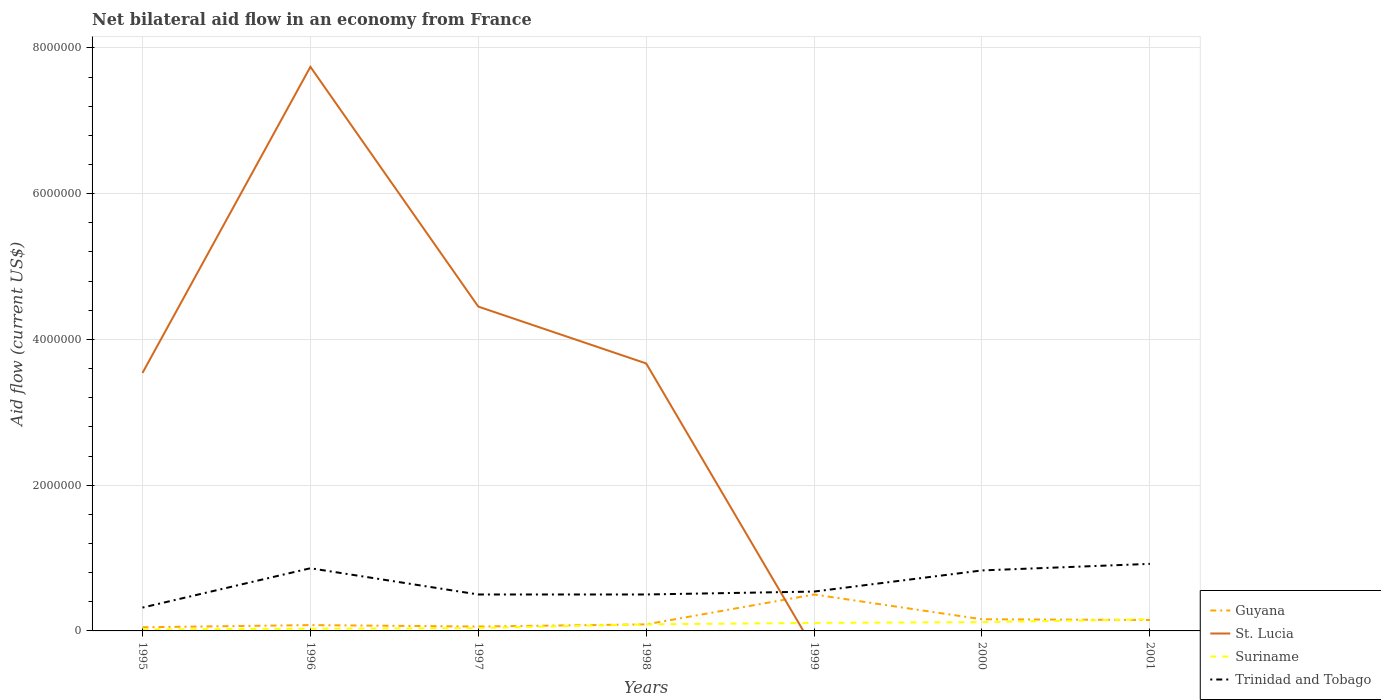Across all years, what is the maximum net bilateral aid flow in Suriname?
Ensure brevity in your answer.  2.00e+04. What is the total net bilateral aid flow in Trinidad and Tobago in the graph?
Offer a terse response. 0. How many lines are there?
Provide a succinct answer. 4. Are the values on the major ticks of Y-axis written in scientific E-notation?
Give a very brief answer. No. Does the graph contain any zero values?
Make the answer very short. Yes. What is the title of the graph?
Make the answer very short. Net bilateral aid flow in an economy from France. Does "Benin" appear as one of the legend labels in the graph?
Make the answer very short. No. What is the Aid flow (current US$) of Guyana in 1995?
Your response must be concise. 5.00e+04. What is the Aid flow (current US$) of St. Lucia in 1995?
Keep it short and to the point. 3.54e+06. What is the Aid flow (current US$) of Suriname in 1995?
Your answer should be very brief. 2.00e+04. What is the Aid flow (current US$) of St. Lucia in 1996?
Ensure brevity in your answer.  7.74e+06. What is the Aid flow (current US$) in Suriname in 1996?
Make the answer very short. 3.00e+04. What is the Aid flow (current US$) in Trinidad and Tobago in 1996?
Ensure brevity in your answer.  8.60e+05. What is the Aid flow (current US$) of Guyana in 1997?
Ensure brevity in your answer.  6.00e+04. What is the Aid flow (current US$) in St. Lucia in 1997?
Make the answer very short. 4.45e+06. What is the Aid flow (current US$) in Suriname in 1997?
Offer a terse response. 4.00e+04. What is the Aid flow (current US$) of St. Lucia in 1998?
Keep it short and to the point. 3.67e+06. What is the Aid flow (current US$) in Suriname in 1998?
Your response must be concise. 9.00e+04. What is the Aid flow (current US$) of Trinidad and Tobago in 1998?
Provide a short and direct response. 5.00e+05. What is the Aid flow (current US$) in Guyana in 1999?
Provide a short and direct response. 5.00e+05. What is the Aid flow (current US$) of Suriname in 1999?
Your answer should be very brief. 1.10e+05. What is the Aid flow (current US$) in Trinidad and Tobago in 1999?
Keep it short and to the point. 5.40e+05. What is the Aid flow (current US$) of St. Lucia in 2000?
Offer a terse response. 0. What is the Aid flow (current US$) in Suriname in 2000?
Offer a very short reply. 1.20e+05. What is the Aid flow (current US$) of Trinidad and Tobago in 2000?
Keep it short and to the point. 8.30e+05. What is the Aid flow (current US$) of Guyana in 2001?
Offer a terse response. 1.50e+05. What is the Aid flow (current US$) in St. Lucia in 2001?
Give a very brief answer. 0. What is the Aid flow (current US$) in Suriname in 2001?
Offer a very short reply. 1.60e+05. What is the Aid flow (current US$) of Trinidad and Tobago in 2001?
Give a very brief answer. 9.20e+05. Across all years, what is the maximum Aid flow (current US$) of St. Lucia?
Provide a short and direct response. 7.74e+06. Across all years, what is the maximum Aid flow (current US$) of Trinidad and Tobago?
Keep it short and to the point. 9.20e+05. Across all years, what is the minimum Aid flow (current US$) of St. Lucia?
Make the answer very short. 0. Across all years, what is the minimum Aid flow (current US$) of Suriname?
Your response must be concise. 2.00e+04. Across all years, what is the minimum Aid flow (current US$) in Trinidad and Tobago?
Your answer should be compact. 3.20e+05. What is the total Aid flow (current US$) in Guyana in the graph?
Provide a short and direct response. 1.09e+06. What is the total Aid flow (current US$) in St. Lucia in the graph?
Make the answer very short. 1.94e+07. What is the total Aid flow (current US$) of Suriname in the graph?
Your answer should be compact. 5.70e+05. What is the total Aid flow (current US$) of Trinidad and Tobago in the graph?
Your response must be concise. 4.47e+06. What is the difference between the Aid flow (current US$) of St. Lucia in 1995 and that in 1996?
Give a very brief answer. -4.20e+06. What is the difference between the Aid flow (current US$) in Suriname in 1995 and that in 1996?
Make the answer very short. -10000. What is the difference between the Aid flow (current US$) in Trinidad and Tobago in 1995 and that in 1996?
Your answer should be very brief. -5.40e+05. What is the difference between the Aid flow (current US$) of Guyana in 1995 and that in 1997?
Offer a very short reply. -10000. What is the difference between the Aid flow (current US$) of St. Lucia in 1995 and that in 1997?
Your response must be concise. -9.10e+05. What is the difference between the Aid flow (current US$) of Guyana in 1995 and that in 1998?
Keep it short and to the point. -4.00e+04. What is the difference between the Aid flow (current US$) in St. Lucia in 1995 and that in 1998?
Make the answer very short. -1.30e+05. What is the difference between the Aid flow (current US$) in Trinidad and Tobago in 1995 and that in 1998?
Your answer should be very brief. -1.80e+05. What is the difference between the Aid flow (current US$) of Guyana in 1995 and that in 1999?
Make the answer very short. -4.50e+05. What is the difference between the Aid flow (current US$) of Guyana in 1995 and that in 2000?
Provide a short and direct response. -1.10e+05. What is the difference between the Aid flow (current US$) of Suriname in 1995 and that in 2000?
Ensure brevity in your answer.  -1.00e+05. What is the difference between the Aid flow (current US$) of Trinidad and Tobago in 1995 and that in 2000?
Your response must be concise. -5.10e+05. What is the difference between the Aid flow (current US$) of Suriname in 1995 and that in 2001?
Your response must be concise. -1.40e+05. What is the difference between the Aid flow (current US$) of Trinidad and Tobago in 1995 and that in 2001?
Provide a succinct answer. -6.00e+05. What is the difference between the Aid flow (current US$) in Guyana in 1996 and that in 1997?
Offer a terse response. 2.00e+04. What is the difference between the Aid flow (current US$) of St. Lucia in 1996 and that in 1997?
Provide a succinct answer. 3.29e+06. What is the difference between the Aid flow (current US$) of Trinidad and Tobago in 1996 and that in 1997?
Make the answer very short. 3.60e+05. What is the difference between the Aid flow (current US$) of St. Lucia in 1996 and that in 1998?
Your response must be concise. 4.07e+06. What is the difference between the Aid flow (current US$) of Suriname in 1996 and that in 1998?
Your response must be concise. -6.00e+04. What is the difference between the Aid flow (current US$) of Guyana in 1996 and that in 1999?
Ensure brevity in your answer.  -4.20e+05. What is the difference between the Aid flow (current US$) in Trinidad and Tobago in 1996 and that in 1999?
Make the answer very short. 3.20e+05. What is the difference between the Aid flow (current US$) in Guyana in 1996 and that in 2000?
Provide a short and direct response. -8.00e+04. What is the difference between the Aid flow (current US$) of Trinidad and Tobago in 1996 and that in 2000?
Provide a succinct answer. 3.00e+04. What is the difference between the Aid flow (current US$) in Guyana in 1996 and that in 2001?
Your response must be concise. -7.00e+04. What is the difference between the Aid flow (current US$) of Suriname in 1996 and that in 2001?
Offer a terse response. -1.30e+05. What is the difference between the Aid flow (current US$) in St. Lucia in 1997 and that in 1998?
Offer a terse response. 7.80e+05. What is the difference between the Aid flow (current US$) of Trinidad and Tobago in 1997 and that in 1998?
Offer a very short reply. 0. What is the difference between the Aid flow (current US$) in Guyana in 1997 and that in 1999?
Offer a very short reply. -4.40e+05. What is the difference between the Aid flow (current US$) of Suriname in 1997 and that in 1999?
Give a very brief answer. -7.00e+04. What is the difference between the Aid flow (current US$) of Guyana in 1997 and that in 2000?
Your response must be concise. -1.00e+05. What is the difference between the Aid flow (current US$) of Suriname in 1997 and that in 2000?
Offer a very short reply. -8.00e+04. What is the difference between the Aid flow (current US$) in Trinidad and Tobago in 1997 and that in 2000?
Keep it short and to the point. -3.30e+05. What is the difference between the Aid flow (current US$) in Suriname in 1997 and that in 2001?
Your answer should be very brief. -1.20e+05. What is the difference between the Aid flow (current US$) in Trinidad and Tobago in 1997 and that in 2001?
Make the answer very short. -4.20e+05. What is the difference between the Aid flow (current US$) of Guyana in 1998 and that in 1999?
Offer a terse response. -4.10e+05. What is the difference between the Aid flow (current US$) of Suriname in 1998 and that in 1999?
Provide a succinct answer. -2.00e+04. What is the difference between the Aid flow (current US$) of Guyana in 1998 and that in 2000?
Your response must be concise. -7.00e+04. What is the difference between the Aid flow (current US$) in Trinidad and Tobago in 1998 and that in 2000?
Your response must be concise. -3.30e+05. What is the difference between the Aid flow (current US$) in Guyana in 1998 and that in 2001?
Your response must be concise. -6.00e+04. What is the difference between the Aid flow (current US$) of Suriname in 1998 and that in 2001?
Keep it short and to the point. -7.00e+04. What is the difference between the Aid flow (current US$) of Trinidad and Tobago in 1998 and that in 2001?
Give a very brief answer. -4.20e+05. What is the difference between the Aid flow (current US$) in Guyana in 1999 and that in 2000?
Your response must be concise. 3.40e+05. What is the difference between the Aid flow (current US$) in Trinidad and Tobago in 1999 and that in 2000?
Provide a succinct answer. -2.90e+05. What is the difference between the Aid flow (current US$) in Guyana in 1999 and that in 2001?
Your answer should be very brief. 3.50e+05. What is the difference between the Aid flow (current US$) of Trinidad and Tobago in 1999 and that in 2001?
Give a very brief answer. -3.80e+05. What is the difference between the Aid flow (current US$) of Guyana in 2000 and that in 2001?
Your answer should be very brief. 10000. What is the difference between the Aid flow (current US$) of Suriname in 2000 and that in 2001?
Your answer should be very brief. -4.00e+04. What is the difference between the Aid flow (current US$) in Trinidad and Tobago in 2000 and that in 2001?
Your answer should be compact. -9.00e+04. What is the difference between the Aid flow (current US$) in Guyana in 1995 and the Aid flow (current US$) in St. Lucia in 1996?
Make the answer very short. -7.69e+06. What is the difference between the Aid flow (current US$) of Guyana in 1995 and the Aid flow (current US$) of Trinidad and Tobago in 1996?
Ensure brevity in your answer.  -8.10e+05. What is the difference between the Aid flow (current US$) of St. Lucia in 1995 and the Aid flow (current US$) of Suriname in 1996?
Your answer should be compact. 3.51e+06. What is the difference between the Aid flow (current US$) in St. Lucia in 1995 and the Aid flow (current US$) in Trinidad and Tobago in 1996?
Offer a terse response. 2.68e+06. What is the difference between the Aid flow (current US$) in Suriname in 1995 and the Aid flow (current US$) in Trinidad and Tobago in 1996?
Keep it short and to the point. -8.40e+05. What is the difference between the Aid flow (current US$) in Guyana in 1995 and the Aid flow (current US$) in St. Lucia in 1997?
Keep it short and to the point. -4.40e+06. What is the difference between the Aid flow (current US$) of Guyana in 1995 and the Aid flow (current US$) of Trinidad and Tobago in 1997?
Your answer should be compact. -4.50e+05. What is the difference between the Aid flow (current US$) of St. Lucia in 1995 and the Aid flow (current US$) of Suriname in 1997?
Your response must be concise. 3.50e+06. What is the difference between the Aid flow (current US$) in St. Lucia in 1995 and the Aid flow (current US$) in Trinidad and Tobago in 1997?
Your answer should be very brief. 3.04e+06. What is the difference between the Aid flow (current US$) in Suriname in 1995 and the Aid flow (current US$) in Trinidad and Tobago in 1997?
Provide a short and direct response. -4.80e+05. What is the difference between the Aid flow (current US$) of Guyana in 1995 and the Aid flow (current US$) of St. Lucia in 1998?
Your response must be concise. -3.62e+06. What is the difference between the Aid flow (current US$) of Guyana in 1995 and the Aid flow (current US$) of Trinidad and Tobago in 1998?
Give a very brief answer. -4.50e+05. What is the difference between the Aid flow (current US$) of St. Lucia in 1995 and the Aid flow (current US$) of Suriname in 1998?
Make the answer very short. 3.45e+06. What is the difference between the Aid flow (current US$) in St. Lucia in 1995 and the Aid flow (current US$) in Trinidad and Tobago in 1998?
Offer a very short reply. 3.04e+06. What is the difference between the Aid flow (current US$) in Suriname in 1995 and the Aid flow (current US$) in Trinidad and Tobago in 1998?
Give a very brief answer. -4.80e+05. What is the difference between the Aid flow (current US$) in Guyana in 1995 and the Aid flow (current US$) in Trinidad and Tobago in 1999?
Your answer should be very brief. -4.90e+05. What is the difference between the Aid flow (current US$) of St. Lucia in 1995 and the Aid flow (current US$) of Suriname in 1999?
Ensure brevity in your answer.  3.43e+06. What is the difference between the Aid flow (current US$) of Suriname in 1995 and the Aid flow (current US$) of Trinidad and Tobago in 1999?
Make the answer very short. -5.20e+05. What is the difference between the Aid flow (current US$) in Guyana in 1995 and the Aid flow (current US$) in Trinidad and Tobago in 2000?
Ensure brevity in your answer.  -7.80e+05. What is the difference between the Aid flow (current US$) in St. Lucia in 1995 and the Aid flow (current US$) in Suriname in 2000?
Offer a terse response. 3.42e+06. What is the difference between the Aid flow (current US$) of St. Lucia in 1995 and the Aid flow (current US$) of Trinidad and Tobago in 2000?
Your answer should be very brief. 2.71e+06. What is the difference between the Aid flow (current US$) in Suriname in 1995 and the Aid flow (current US$) in Trinidad and Tobago in 2000?
Provide a succinct answer. -8.10e+05. What is the difference between the Aid flow (current US$) of Guyana in 1995 and the Aid flow (current US$) of Trinidad and Tobago in 2001?
Make the answer very short. -8.70e+05. What is the difference between the Aid flow (current US$) in St. Lucia in 1995 and the Aid flow (current US$) in Suriname in 2001?
Ensure brevity in your answer.  3.38e+06. What is the difference between the Aid flow (current US$) of St. Lucia in 1995 and the Aid flow (current US$) of Trinidad and Tobago in 2001?
Your answer should be compact. 2.62e+06. What is the difference between the Aid flow (current US$) in Suriname in 1995 and the Aid flow (current US$) in Trinidad and Tobago in 2001?
Your answer should be very brief. -9.00e+05. What is the difference between the Aid flow (current US$) of Guyana in 1996 and the Aid flow (current US$) of St. Lucia in 1997?
Provide a succinct answer. -4.37e+06. What is the difference between the Aid flow (current US$) in Guyana in 1996 and the Aid flow (current US$) in Trinidad and Tobago in 1997?
Your answer should be very brief. -4.20e+05. What is the difference between the Aid flow (current US$) in St. Lucia in 1996 and the Aid flow (current US$) in Suriname in 1997?
Provide a succinct answer. 7.70e+06. What is the difference between the Aid flow (current US$) in St. Lucia in 1996 and the Aid flow (current US$) in Trinidad and Tobago in 1997?
Offer a terse response. 7.24e+06. What is the difference between the Aid flow (current US$) in Suriname in 1996 and the Aid flow (current US$) in Trinidad and Tobago in 1997?
Offer a very short reply. -4.70e+05. What is the difference between the Aid flow (current US$) in Guyana in 1996 and the Aid flow (current US$) in St. Lucia in 1998?
Provide a short and direct response. -3.59e+06. What is the difference between the Aid flow (current US$) of Guyana in 1996 and the Aid flow (current US$) of Suriname in 1998?
Ensure brevity in your answer.  -10000. What is the difference between the Aid flow (current US$) of Guyana in 1996 and the Aid flow (current US$) of Trinidad and Tobago in 1998?
Ensure brevity in your answer.  -4.20e+05. What is the difference between the Aid flow (current US$) of St. Lucia in 1996 and the Aid flow (current US$) of Suriname in 1998?
Give a very brief answer. 7.65e+06. What is the difference between the Aid flow (current US$) of St. Lucia in 1996 and the Aid flow (current US$) of Trinidad and Tobago in 1998?
Make the answer very short. 7.24e+06. What is the difference between the Aid flow (current US$) of Suriname in 1996 and the Aid flow (current US$) of Trinidad and Tobago in 1998?
Offer a terse response. -4.70e+05. What is the difference between the Aid flow (current US$) of Guyana in 1996 and the Aid flow (current US$) of Suriname in 1999?
Your response must be concise. -3.00e+04. What is the difference between the Aid flow (current US$) in Guyana in 1996 and the Aid flow (current US$) in Trinidad and Tobago in 1999?
Give a very brief answer. -4.60e+05. What is the difference between the Aid flow (current US$) of St. Lucia in 1996 and the Aid flow (current US$) of Suriname in 1999?
Ensure brevity in your answer.  7.63e+06. What is the difference between the Aid flow (current US$) in St. Lucia in 1996 and the Aid flow (current US$) in Trinidad and Tobago in 1999?
Provide a short and direct response. 7.20e+06. What is the difference between the Aid flow (current US$) in Suriname in 1996 and the Aid flow (current US$) in Trinidad and Tobago in 1999?
Your answer should be very brief. -5.10e+05. What is the difference between the Aid flow (current US$) of Guyana in 1996 and the Aid flow (current US$) of Trinidad and Tobago in 2000?
Offer a very short reply. -7.50e+05. What is the difference between the Aid flow (current US$) in St. Lucia in 1996 and the Aid flow (current US$) in Suriname in 2000?
Your response must be concise. 7.62e+06. What is the difference between the Aid flow (current US$) in St. Lucia in 1996 and the Aid flow (current US$) in Trinidad and Tobago in 2000?
Ensure brevity in your answer.  6.91e+06. What is the difference between the Aid flow (current US$) of Suriname in 1996 and the Aid flow (current US$) of Trinidad and Tobago in 2000?
Give a very brief answer. -8.00e+05. What is the difference between the Aid flow (current US$) of Guyana in 1996 and the Aid flow (current US$) of Trinidad and Tobago in 2001?
Your answer should be very brief. -8.40e+05. What is the difference between the Aid flow (current US$) of St. Lucia in 1996 and the Aid flow (current US$) of Suriname in 2001?
Offer a terse response. 7.58e+06. What is the difference between the Aid flow (current US$) of St. Lucia in 1996 and the Aid flow (current US$) of Trinidad and Tobago in 2001?
Give a very brief answer. 6.82e+06. What is the difference between the Aid flow (current US$) of Suriname in 1996 and the Aid flow (current US$) of Trinidad and Tobago in 2001?
Make the answer very short. -8.90e+05. What is the difference between the Aid flow (current US$) of Guyana in 1997 and the Aid flow (current US$) of St. Lucia in 1998?
Offer a terse response. -3.61e+06. What is the difference between the Aid flow (current US$) of Guyana in 1997 and the Aid flow (current US$) of Trinidad and Tobago in 1998?
Give a very brief answer. -4.40e+05. What is the difference between the Aid flow (current US$) of St. Lucia in 1997 and the Aid flow (current US$) of Suriname in 1998?
Your response must be concise. 4.36e+06. What is the difference between the Aid flow (current US$) of St. Lucia in 1997 and the Aid flow (current US$) of Trinidad and Tobago in 1998?
Offer a very short reply. 3.95e+06. What is the difference between the Aid flow (current US$) of Suriname in 1997 and the Aid flow (current US$) of Trinidad and Tobago in 1998?
Offer a very short reply. -4.60e+05. What is the difference between the Aid flow (current US$) in Guyana in 1997 and the Aid flow (current US$) in Trinidad and Tobago in 1999?
Ensure brevity in your answer.  -4.80e+05. What is the difference between the Aid flow (current US$) in St. Lucia in 1997 and the Aid flow (current US$) in Suriname in 1999?
Ensure brevity in your answer.  4.34e+06. What is the difference between the Aid flow (current US$) in St. Lucia in 1997 and the Aid flow (current US$) in Trinidad and Tobago in 1999?
Your response must be concise. 3.91e+06. What is the difference between the Aid flow (current US$) of Suriname in 1997 and the Aid flow (current US$) of Trinidad and Tobago in 1999?
Provide a succinct answer. -5.00e+05. What is the difference between the Aid flow (current US$) in Guyana in 1997 and the Aid flow (current US$) in Trinidad and Tobago in 2000?
Give a very brief answer. -7.70e+05. What is the difference between the Aid flow (current US$) of St. Lucia in 1997 and the Aid flow (current US$) of Suriname in 2000?
Keep it short and to the point. 4.33e+06. What is the difference between the Aid flow (current US$) of St. Lucia in 1997 and the Aid flow (current US$) of Trinidad and Tobago in 2000?
Give a very brief answer. 3.62e+06. What is the difference between the Aid flow (current US$) in Suriname in 1997 and the Aid flow (current US$) in Trinidad and Tobago in 2000?
Your response must be concise. -7.90e+05. What is the difference between the Aid flow (current US$) in Guyana in 1997 and the Aid flow (current US$) in Suriname in 2001?
Offer a very short reply. -1.00e+05. What is the difference between the Aid flow (current US$) of Guyana in 1997 and the Aid flow (current US$) of Trinidad and Tobago in 2001?
Your answer should be compact. -8.60e+05. What is the difference between the Aid flow (current US$) in St. Lucia in 1997 and the Aid flow (current US$) in Suriname in 2001?
Your answer should be very brief. 4.29e+06. What is the difference between the Aid flow (current US$) of St. Lucia in 1997 and the Aid flow (current US$) of Trinidad and Tobago in 2001?
Give a very brief answer. 3.53e+06. What is the difference between the Aid flow (current US$) of Suriname in 1997 and the Aid flow (current US$) of Trinidad and Tobago in 2001?
Your answer should be very brief. -8.80e+05. What is the difference between the Aid flow (current US$) in Guyana in 1998 and the Aid flow (current US$) in Trinidad and Tobago in 1999?
Your response must be concise. -4.50e+05. What is the difference between the Aid flow (current US$) of St. Lucia in 1998 and the Aid flow (current US$) of Suriname in 1999?
Provide a succinct answer. 3.56e+06. What is the difference between the Aid flow (current US$) of St. Lucia in 1998 and the Aid flow (current US$) of Trinidad and Tobago in 1999?
Your response must be concise. 3.13e+06. What is the difference between the Aid flow (current US$) in Suriname in 1998 and the Aid flow (current US$) in Trinidad and Tobago in 1999?
Ensure brevity in your answer.  -4.50e+05. What is the difference between the Aid flow (current US$) in Guyana in 1998 and the Aid flow (current US$) in Suriname in 2000?
Your response must be concise. -3.00e+04. What is the difference between the Aid flow (current US$) of Guyana in 1998 and the Aid flow (current US$) of Trinidad and Tobago in 2000?
Provide a short and direct response. -7.40e+05. What is the difference between the Aid flow (current US$) of St. Lucia in 1998 and the Aid flow (current US$) of Suriname in 2000?
Ensure brevity in your answer.  3.55e+06. What is the difference between the Aid flow (current US$) of St. Lucia in 1998 and the Aid flow (current US$) of Trinidad and Tobago in 2000?
Provide a short and direct response. 2.84e+06. What is the difference between the Aid flow (current US$) in Suriname in 1998 and the Aid flow (current US$) in Trinidad and Tobago in 2000?
Keep it short and to the point. -7.40e+05. What is the difference between the Aid flow (current US$) in Guyana in 1998 and the Aid flow (current US$) in Trinidad and Tobago in 2001?
Your answer should be compact. -8.30e+05. What is the difference between the Aid flow (current US$) of St. Lucia in 1998 and the Aid flow (current US$) of Suriname in 2001?
Provide a short and direct response. 3.51e+06. What is the difference between the Aid flow (current US$) of St. Lucia in 1998 and the Aid flow (current US$) of Trinidad and Tobago in 2001?
Ensure brevity in your answer.  2.75e+06. What is the difference between the Aid flow (current US$) of Suriname in 1998 and the Aid flow (current US$) of Trinidad and Tobago in 2001?
Your response must be concise. -8.30e+05. What is the difference between the Aid flow (current US$) of Guyana in 1999 and the Aid flow (current US$) of Suriname in 2000?
Your answer should be compact. 3.80e+05. What is the difference between the Aid flow (current US$) in Guyana in 1999 and the Aid flow (current US$) in Trinidad and Tobago in 2000?
Your answer should be compact. -3.30e+05. What is the difference between the Aid flow (current US$) in Suriname in 1999 and the Aid flow (current US$) in Trinidad and Tobago in 2000?
Make the answer very short. -7.20e+05. What is the difference between the Aid flow (current US$) of Guyana in 1999 and the Aid flow (current US$) of Trinidad and Tobago in 2001?
Make the answer very short. -4.20e+05. What is the difference between the Aid flow (current US$) in Suriname in 1999 and the Aid flow (current US$) in Trinidad and Tobago in 2001?
Provide a short and direct response. -8.10e+05. What is the difference between the Aid flow (current US$) in Guyana in 2000 and the Aid flow (current US$) in Suriname in 2001?
Give a very brief answer. 0. What is the difference between the Aid flow (current US$) of Guyana in 2000 and the Aid flow (current US$) of Trinidad and Tobago in 2001?
Your answer should be very brief. -7.60e+05. What is the difference between the Aid flow (current US$) of Suriname in 2000 and the Aid flow (current US$) of Trinidad and Tobago in 2001?
Give a very brief answer. -8.00e+05. What is the average Aid flow (current US$) in Guyana per year?
Keep it short and to the point. 1.56e+05. What is the average Aid flow (current US$) of St. Lucia per year?
Your answer should be compact. 2.77e+06. What is the average Aid flow (current US$) in Suriname per year?
Your response must be concise. 8.14e+04. What is the average Aid flow (current US$) in Trinidad and Tobago per year?
Provide a short and direct response. 6.39e+05. In the year 1995, what is the difference between the Aid flow (current US$) of Guyana and Aid flow (current US$) of St. Lucia?
Make the answer very short. -3.49e+06. In the year 1995, what is the difference between the Aid flow (current US$) of St. Lucia and Aid flow (current US$) of Suriname?
Keep it short and to the point. 3.52e+06. In the year 1995, what is the difference between the Aid flow (current US$) in St. Lucia and Aid flow (current US$) in Trinidad and Tobago?
Make the answer very short. 3.22e+06. In the year 1995, what is the difference between the Aid flow (current US$) of Suriname and Aid flow (current US$) of Trinidad and Tobago?
Your response must be concise. -3.00e+05. In the year 1996, what is the difference between the Aid flow (current US$) of Guyana and Aid flow (current US$) of St. Lucia?
Keep it short and to the point. -7.66e+06. In the year 1996, what is the difference between the Aid flow (current US$) in Guyana and Aid flow (current US$) in Trinidad and Tobago?
Make the answer very short. -7.80e+05. In the year 1996, what is the difference between the Aid flow (current US$) of St. Lucia and Aid flow (current US$) of Suriname?
Offer a very short reply. 7.71e+06. In the year 1996, what is the difference between the Aid flow (current US$) in St. Lucia and Aid flow (current US$) in Trinidad and Tobago?
Offer a very short reply. 6.88e+06. In the year 1996, what is the difference between the Aid flow (current US$) of Suriname and Aid flow (current US$) of Trinidad and Tobago?
Your response must be concise. -8.30e+05. In the year 1997, what is the difference between the Aid flow (current US$) in Guyana and Aid flow (current US$) in St. Lucia?
Offer a very short reply. -4.39e+06. In the year 1997, what is the difference between the Aid flow (current US$) in Guyana and Aid flow (current US$) in Suriname?
Provide a succinct answer. 2.00e+04. In the year 1997, what is the difference between the Aid flow (current US$) of Guyana and Aid flow (current US$) of Trinidad and Tobago?
Provide a short and direct response. -4.40e+05. In the year 1997, what is the difference between the Aid flow (current US$) of St. Lucia and Aid flow (current US$) of Suriname?
Keep it short and to the point. 4.41e+06. In the year 1997, what is the difference between the Aid flow (current US$) of St. Lucia and Aid flow (current US$) of Trinidad and Tobago?
Make the answer very short. 3.95e+06. In the year 1997, what is the difference between the Aid flow (current US$) of Suriname and Aid flow (current US$) of Trinidad and Tobago?
Your answer should be very brief. -4.60e+05. In the year 1998, what is the difference between the Aid flow (current US$) in Guyana and Aid flow (current US$) in St. Lucia?
Your answer should be compact. -3.58e+06. In the year 1998, what is the difference between the Aid flow (current US$) in Guyana and Aid flow (current US$) in Suriname?
Provide a short and direct response. 0. In the year 1998, what is the difference between the Aid flow (current US$) of Guyana and Aid flow (current US$) of Trinidad and Tobago?
Offer a terse response. -4.10e+05. In the year 1998, what is the difference between the Aid flow (current US$) of St. Lucia and Aid flow (current US$) of Suriname?
Provide a short and direct response. 3.58e+06. In the year 1998, what is the difference between the Aid flow (current US$) of St. Lucia and Aid flow (current US$) of Trinidad and Tobago?
Your answer should be very brief. 3.17e+06. In the year 1998, what is the difference between the Aid flow (current US$) of Suriname and Aid flow (current US$) of Trinidad and Tobago?
Offer a terse response. -4.10e+05. In the year 1999, what is the difference between the Aid flow (current US$) in Guyana and Aid flow (current US$) in Suriname?
Your response must be concise. 3.90e+05. In the year 1999, what is the difference between the Aid flow (current US$) of Suriname and Aid flow (current US$) of Trinidad and Tobago?
Your answer should be very brief. -4.30e+05. In the year 2000, what is the difference between the Aid flow (current US$) in Guyana and Aid flow (current US$) in Suriname?
Your answer should be very brief. 4.00e+04. In the year 2000, what is the difference between the Aid flow (current US$) of Guyana and Aid flow (current US$) of Trinidad and Tobago?
Give a very brief answer. -6.70e+05. In the year 2000, what is the difference between the Aid flow (current US$) in Suriname and Aid flow (current US$) in Trinidad and Tobago?
Your response must be concise. -7.10e+05. In the year 2001, what is the difference between the Aid flow (current US$) of Guyana and Aid flow (current US$) of Trinidad and Tobago?
Provide a short and direct response. -7.70e+05. In the year 2001, what is the difference between the Aid flow (current US$) of Suriname and Aid flow (current US$) of Trinidad and Tobago?
Provide a succinct answer. -7.60e+05. What is the ratio of the Aid flow (current US$) in Guyana in 1995 to that in 1996?
Keep it short and to the point. 0.62. What is the ratio of the Aid flow (current US$) of St. Lucia in 1995 to that in 1996?
Keep it short and to the point. 0.46. What is the ratio of the Aid flow (current US$) in Suriname in 1995 to that in 1996?
Offer a terse response. 0.67. What is the ratio of the Aid flow (current US$) of Trinidad and Tobago in 1995 to that in 1996?
Provide a succinct answer. 0.37. What is the ratio of the Aid flow (current US$) in St. Lucia in 1995 to that in 1997?
Offer a very short reply. 0.8. What is the ratio of the Aid flow (current US$) of Trinidad and Tobago in 1995 to that in 1997?
Your answer should be compact. 0.64. What is the ratio of the Aid flow (current US$) of Guyana in 1995 to that in 1998?
Your answer should be compact. 0.56. What is the ratio of the Aid flow (current US$) in St. Lucia in 1995 to that in 1998?
Offer a very short reply. 0.96. What is the ratio of the Aid flow (current US$) of Suriname in 1995 to that in 1998?
Your answer should be very brief. 0.22. What is the ratio of the Aid flow (current US$) of Trinidad and Tobago in 1995 to that in 1998?
Give a very brief answer. 0.64. What is the ratio of the Aid flow (current US$) in Suriname in 1995 to that in 1999?
Make the answer very short. 0.18. What is the ratio of the Aid flow (current US$) of Trinidad and Tobago in 1995 to that in 1999?
Your answer should be very brief. 0.59. What is the ratio of the Aid flow (current US$) in Guyana in 1995 to that in 2000?
Your answer should be very brief. 0.31. What is the ratio of the Aid flow (current US$) of Suriname in 1995 to that in 2000?
Offer a very short reply. 0.17. What is the ratio of the Aid flow (current US$) in Trinidad and Tobago in 1995 to that in 2000?
Keep it short and to the point. 0.39. What is the ratio of the Aid flow (current US$) of Guyana in 1995 to that in 2001?
Your answer should be compact. 0.33. What is the ratio of the Aid flow (current US$) in Trinidad and Tobago in 1995 to that in 2001?
Provide a short and direct response. 0.35. What is the ratio of the Aid flow (current US$) of Guyana in 1996 to that in 1997?
Provide a short and direct response. 1.33. What is the ratio of the Aid flow (current US$) in St. Lucia in 1996 to that in 1997?
Offer a terse response. 1.74. What is the ratio of the Aid flow (current US$) in Suriname in 1996 to that in 1997?
Your response must be concise. 0.75. What is the ratio of the Aid flow (current US$) in Trinidad and Tobago in 1996 to that in 1997?
Your response must be concise. 1.72. What is the ratio of the Aid flow (current US$) in St. Lucia in 1996 to that in 1998?
Offer a terse response. 2.11. What is the ratio of the Aid flow (current US$) in Trinidad and Tobago in 1996 to that in 1998?
Offer a very short reply. 1.72. What is the ratio of the Aid flow (current US$) in Guyana in 1996 to that in 1999?
Ensure brevity in your answer.  0.16. What is the ratio of the Aid flow (current US$) in Suriname in 1996 to that in 1999?
Your answer should be compact. 0.27. What is the ratio of the Aid flow (current US$) in Trinidad and Tobago in 1996 to that in 1999?
Offer a terse response. 1.59. What is the ratio of the Aid flow (current US$) in Guyana in 1996 to that in 2000?
Your answer should be very brief. 0.5. What is the ratio of the Aid flow (current US$) of Trinidad and Tobago in 1996 to that in 2000?
Your answer should be very brief. 1.04. What is the ratio of the Aid flow (current US$) of Guyana in 1996 to that in 2001?
Your response must be concise. 0.53. What is the ratio of the Aid flow (current US$) in Suriname in 1996 to that in 2001?
Offer a terse response. 0.19. What is the ratio of the Aid flow (current US$) in Trinidad and Tobago in 1996 to that in 2001?
Your response must be concise. 0.93. What is the ratio of the Aid flow (current US$) in St. Lucia in 1997 to that in 1998?
Make the answer very short. 1.21. What is the ratio of the Aid flow (current US$) in Suriname in 1997 to that in 1998?
Provide a succinct answer. 0.44. What is the ratio of the Aid flow (current US$) in Trinidad and Tobago in 1997 to that in 1998?
Give a very brief answer. 1. What is the ratio of the Aid flow (current US$) in Guyana in 1997 to that in 1999?
Offer a terse response. 0.12. What is the ratio of the Aid flow (current US$) of Suriname in 1997 to that in 1999?
Your answer should be very brief. 0.36. What is the ratio of the Aid flow (current US$) in Trinidad and Tobago in 1997 to that in 1999?
Keep it short and to the point. 0.93. What is the ratio of the Aid flow (current US$) of Suriname in 1997 to that in 2000?
Your response must be concise. 0.33. What is the ratio of the Aid flow (current US$) of Trinidad and Tobago in 1997 to that in 2000?
Provide a short and direct response. 0.6. What is the ratio of the Aid flow (current US$) in Guyana in 1997 to that in 2001?
Your answer should be very brief. 0.4. What is the ratio of the Aid flow (current US$) in Suriname in 1997 to that in 2001?
Keep it short and to the point. 0.25. What is the ratio of the Aid flow (current US$) of Trinidad and Tobago in 1997 to that in 2001?
Offer a very short reply. 0.54. What is the ratio of the Aid flow (current US$) of Guyana in 1998 to that in 1999?
Offer a very short reply. 0.18. What is the ratio of the Aid flow (current US$) in Suriname in 1998 to that in 1999?
Offer a terse response. 0.82. What is the ratio of the Aid flow (current US$) of Trinidad and Tobago in 1998 to that in 1999?
Provide a short and direct response. 0.93. What is the ratio of the Aid flow (current US$) in Guyana in 1998 to that in 2000?
Ensure brevity in your answer.  0.56. What is the ratio of the Aid flow (current US$) in Suriname in 1998 to that in 2000?
Your answer should be compact. 0.75. What is the ratio of the Aid flow (current US$) in Trinidad and Tobago in 1998 to that in 2000?
Ensure brevity in your answer.  0.6. What is the ratio of the Aid flow (current US$) of Guyana in 1998 to that in 2001?
Provide a succinct answer. 0.6. What is the ratio of the Aid flow (current US$) in Suriname in 1998 to that in 2001?
Offer a terse response. 0.56. What is the ratio of the Aid flow (current US$) of Trinidad and Tobago in 1998 to that in 2001?
Your response must be concise. 0.54. What is the ratio of the Aid flow (current US$) in Guyana in 1999 to that in 2000?
Your answer should be very brief. 3.12. What is the ratio of the Aid flow (current US$) of Trinidad and Tobago in 1999 to that in 2000?
Provide a short and direct response. 0.65. What is the ratio of the Aid flow (current US$) of Guyana in 1999 to that in 2001?
Make the answer very short. 3.33. What is the ratio of the Aid flow (current US$) of Suriname in 1999 to that in 2001?
Give a very brief answer. 0.69. What is the ratio of the Aid flow (current US$) of Trinidad and Tobago in 1999 to that in 2001?
Make the answer very short. 0.59. What is the ratio of the Aid flow (current US$) of Guyana in 2000 to that in 2001?
Provide a short and direct response. 1.07. What is the ratio of the Aid flow (current US$) of Suriname in 2000 to that in 2001?
Ensure brevity in your answer.  0.75. What is the ratio of the Aid flow (current US$) in Trinidad and Tobago in 2000 to that in 2001?
Make the answer very short. 0.9. What is the difference between the highest and the second highest Aid flow (current US$) in St. Lucia?
Provide a short and direct response. 3.29e+06. What is the difference between the highest and the second highest Aid flow (current US$) in Suriname?
Your answer should be very brief. 4.00e+04. What is the difference between the highest and the lowest Aid flow (current US$) of Guyana?
Your answer should be very brief. 4.50e+05. What is the difference between the highest and the lowest Aid flow (current US$) of St. Lucia?
Give a very brief answer. 7.74e+06. What is the difference between the highest and the lowest Aid flow (current US$) of Trinidad and Tobago?
Give a very brief answer. 6.00e+05. 